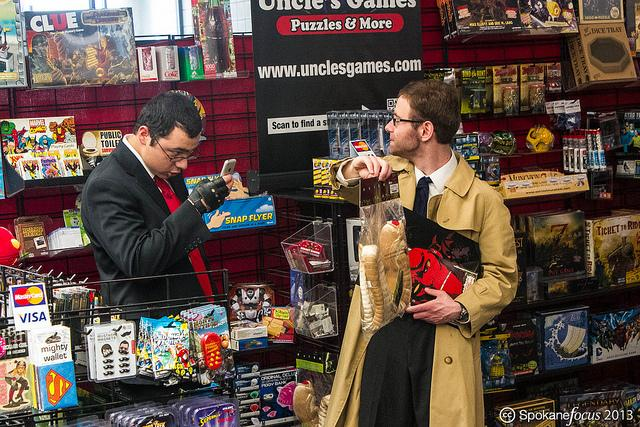What superhero's logo is printed on a wallet in front of the Visa sign? superman 